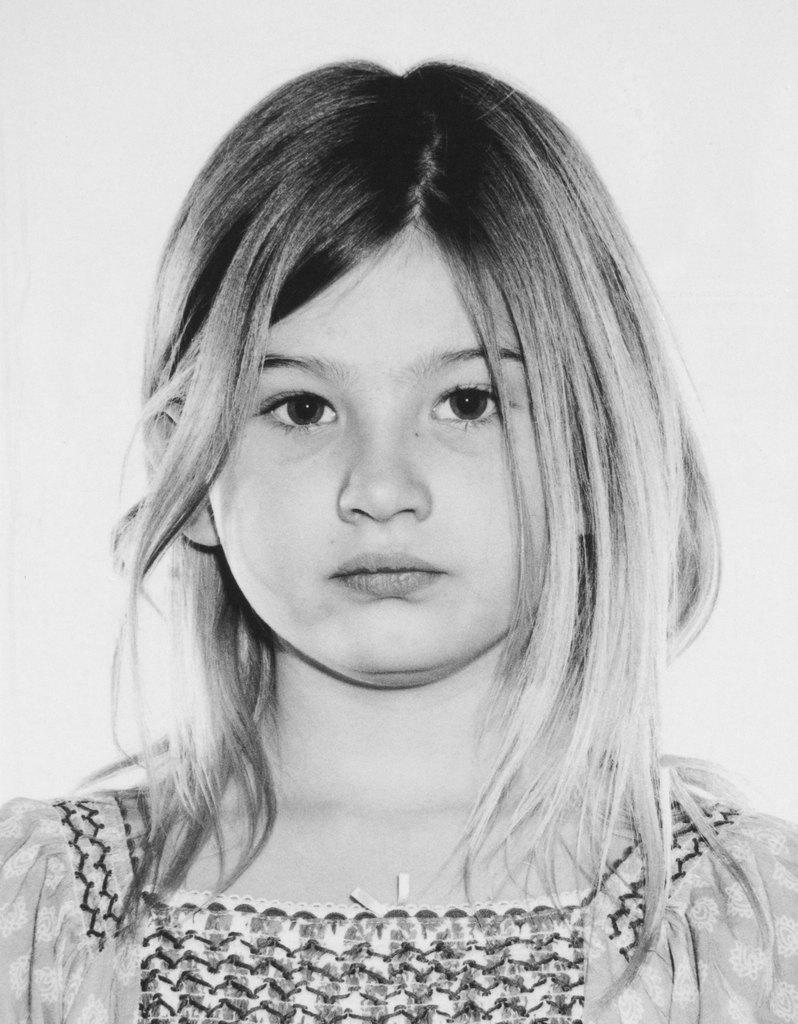What is the color scheme of the image? The image is black and white. Who is present in the image? There is a girl in the image. What is the girl wearing? The girl is wearing a frock. What is the girl doing in the image? The girl is looking at a picture. Is there a crook in the image trying to steal the girl's frock? No, there is no crook present in the image. 